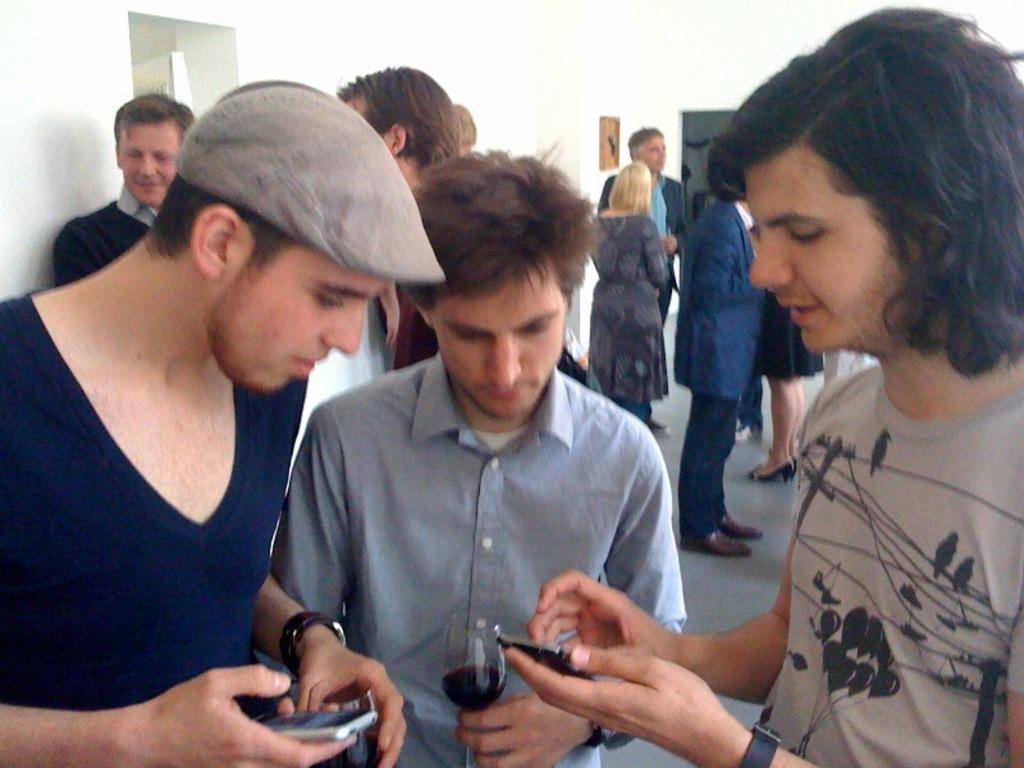Who or what is present in the image? There are people in the image. What are two of the people doing in the image? Two men are holding mobiles. What can be seen in the background of the image? There are objects on the wall in the background of the image. What type of thunder can be heard in the image? There is no thunder present in the image, as it is a visual medium and does not contain sound. 